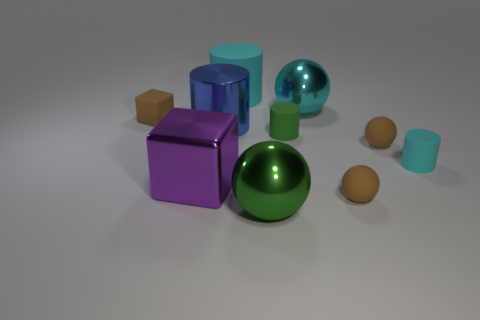Subtract all large cyan rubber cylinders. How many cylinders are left? 3 Subtract all brown cubes. How many cubes are left? 1 Subtract all balls. How many objects are left? 6 Subtract 4 cylinders. How many cylinders are left? 0 Subtract all blue spheres. Subtract all cyan cylinders. How many spheres are left? 4 Subtract all purple spheres. How many cyan cylinders are left? 2 Subtract all red matte things. Subtract all big metallic things. How many objects are left? 6 Add 7 big matte cylinders. How many big matte cylinders are left? 8 Add 3 spheres. How many spheres exist? 7 Subtract 0 red blocks. How many objects are left? 10 